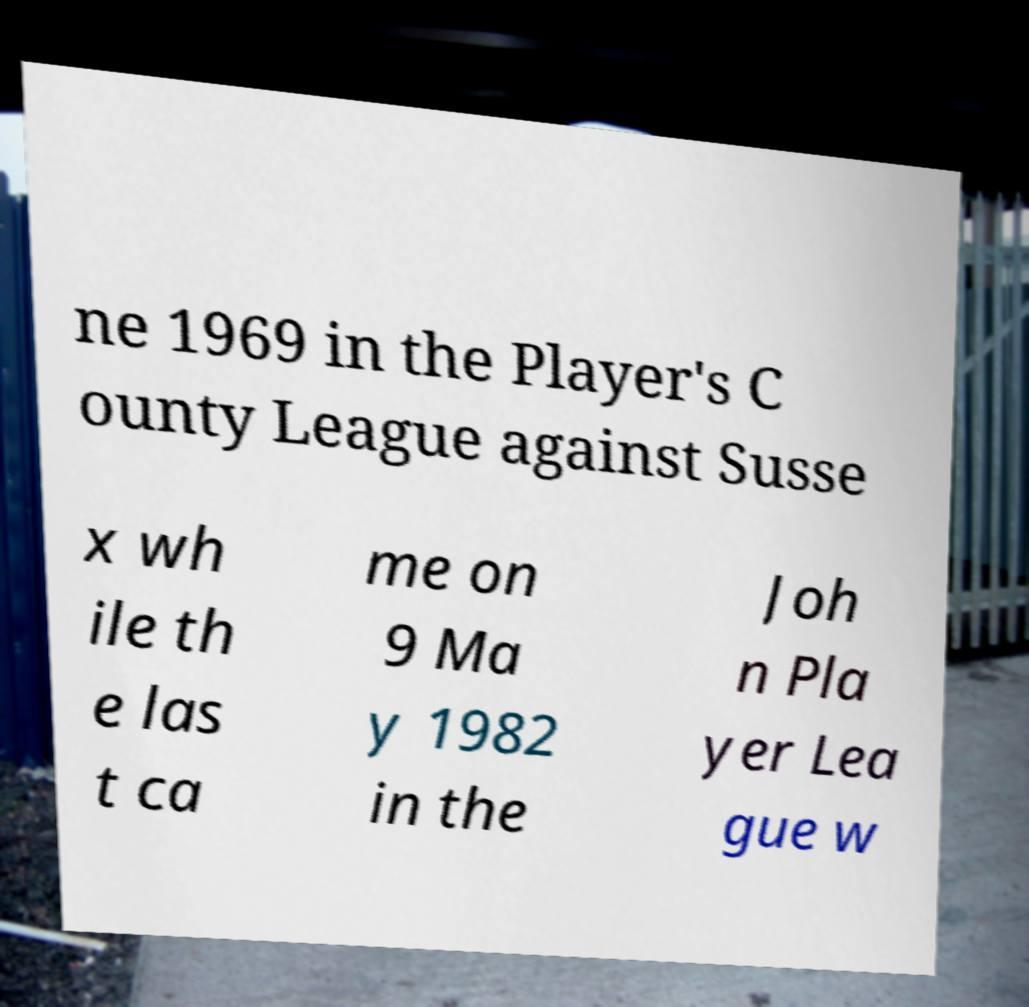What messages or text are displayed in this image? I need them in a readable, typed format. ne 1969 in the Player's C ounty League against Susse x wh ile th e las t ca me on 9 Ma y 1982 in the Joh n Pla yer Lea gue w 